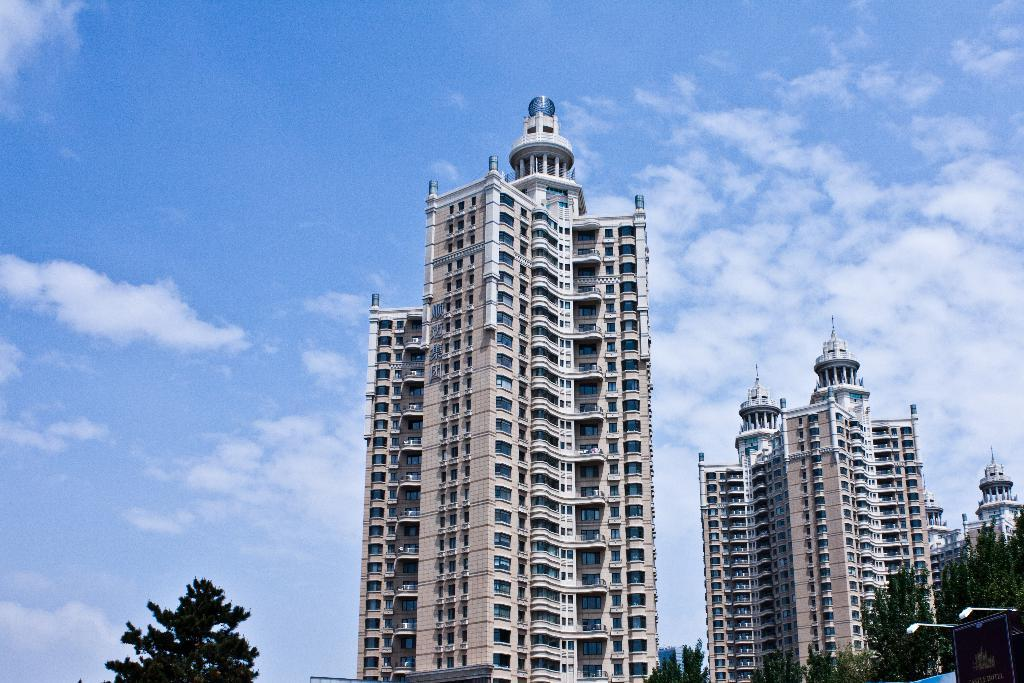What type of structures are present in the image? There is a group of buildings in the image. What other elements can be seen in the image besides the buildings? There are trees, poles, and a poster visible in the image. Where is the poster located in the image? The poster is on the right side of the image. What is visible in the background of the image? The sky is visible in the background of the image. How would you describe the sky in the image? The sky appears to be cloudy in the image. How many birds are perched on the roof of the building in the image? There are no birds visible in the image, and there is no mention of a roof for any of the buildings. 